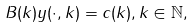<formula> <loc_0><loc_0><loc_500><loc_500>B ( k ) y ( \cdot , k ) = c ( k ) , k \in \mathbb { N } ,</formula> 